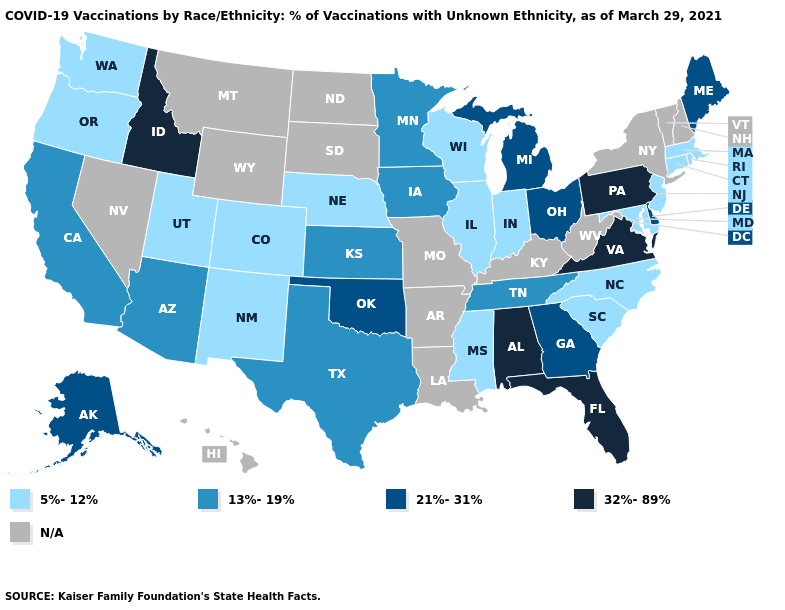Does the map have missing data?
Quick response, please. Yes. What is the value of Nebraska?
Answer briefly. 5%-12%. How many symbols are there in the legend?
Short answer required. 5. What is the value of Georgia?
Keep it brief. 21%-31%. Does Wisconsin have the lowest value in the USA?
Short answer required. Yes. What is the highest value in states that border Colorado?
Keep it brief. 21%-31%. What is the lowest value in the USA?
Be succinct. 5%-12%. What is the value of Pennsylvania?
Be succinct. 32%-89%. Which states hav the highest value in the South?
Answer briefly. Alabama, Florida, Virginia. Does the first symbol in the legend represent the smallest category?
Concise answer only. Yes. Is the legend a continuous bar?
Keep it brief. No. What is the value of Mississippi?
Quick response, please. 5%-12%. What is the lowest value in the USA?
Short answer required. 5%-12%. Which states have the highest value in the USA?
Write a very short answer. Alabama, Florida, Idaho, Pennsylvania, Virginia. 